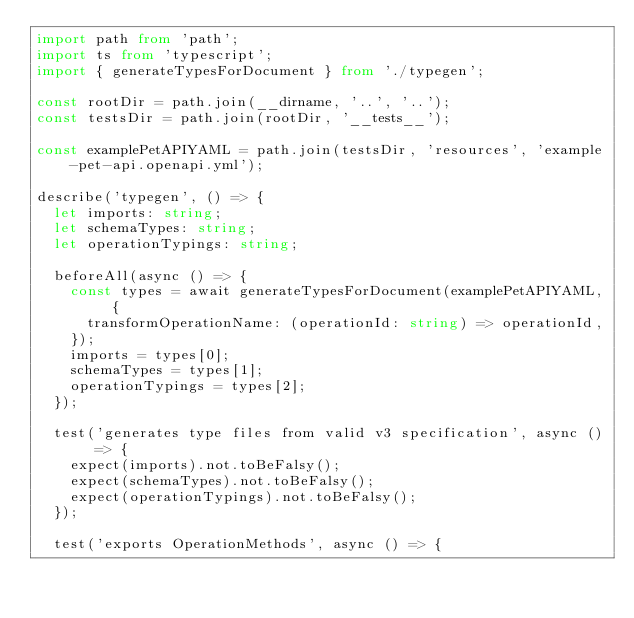<code> <loc_0><loc_0><loc_500><loc_500><_TypeScript_>import path from 'path';
import ts from 'typescript';
import { generateTypesForDocument } from './typegen';

const rootDir = path.join(__dirname, '..', '..');
const testsDir = path.join(rootDir, '__tests__');

const examplePetAPIYAML = path.join(testsDir, 'resources', 'example-pet-api.openapi.yml');

describe('typegen', () => {
  let imports: string;
  let schemaTypes: string;
  let operationTypings: string;

  beforeAll(async () => {
    const types = await generateTypesForDocument(examplePetAPIYAML, {
      transformOperationName: (operationId: string) => operationId,
    });
    imports = types[0];
    schemaTypes = types[1];
    operationTypings = types[2];
  });

  test('generates type files from valid v3 specification', async () => {
    expect(imports).not.toBeFalsy();
    expect(schemaTypes).not.toBeFalsy();
    expect(operationTypings).not.toBeFalsy();
  });

  test('exports OperationMethods', async () => {</code> 